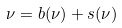<formula> <loc_0><loc_0><loc_500><loc_500>\nu = { b } ( \nu ) + { s } ( \nu )</formula> 